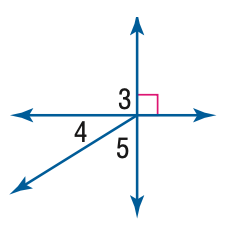Answer the mathemtical geometry problem and directly provide the correct option letter.
Question: m \angle 4 = 32. Find the measure of \angle 5.
Choices: A: 32 B: 58 C: 68 D: 90 B 